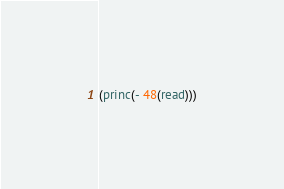<code> <loc_0><loc_0><loc_500><loc_500><_Lisp_>(princ(- 48(read)))</code> 